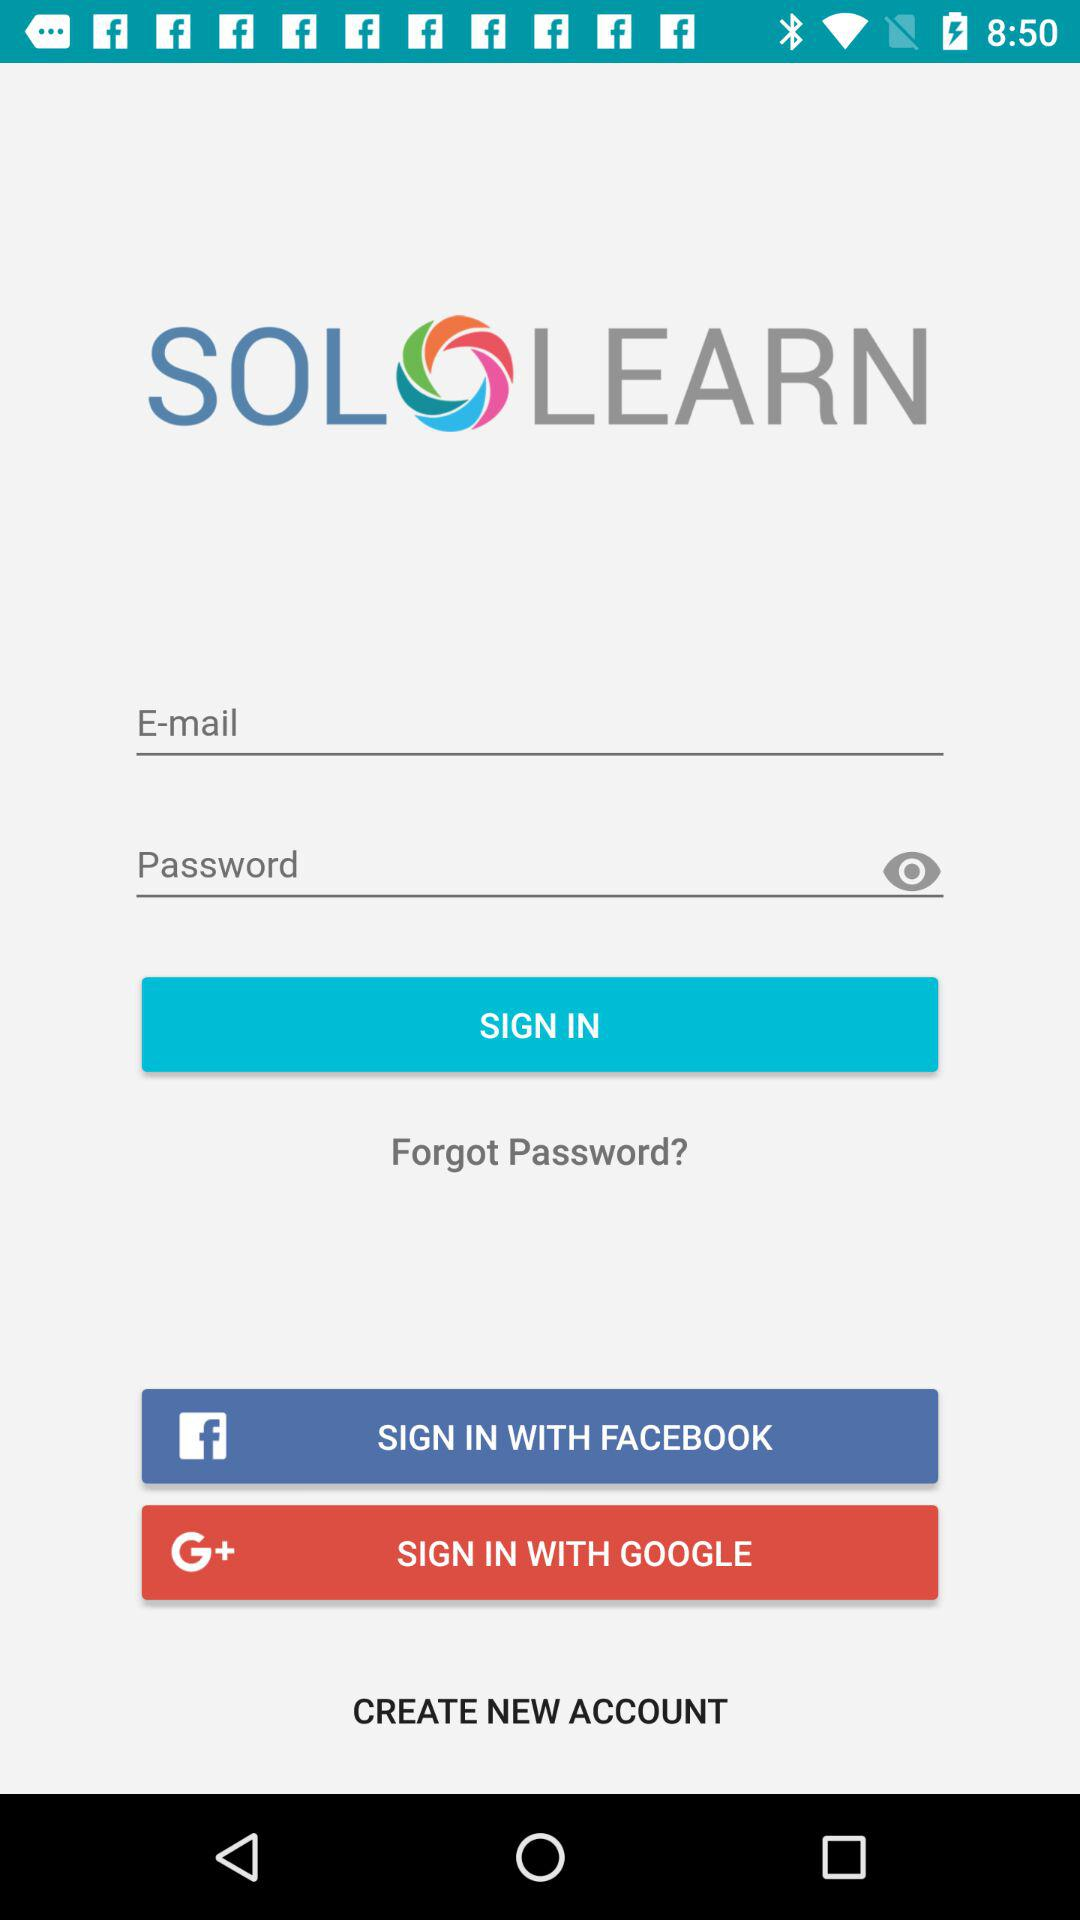Which options are given to sign in? The options given to sign in are "E-mail", "FACEBOOK" and "GOOGLE". 